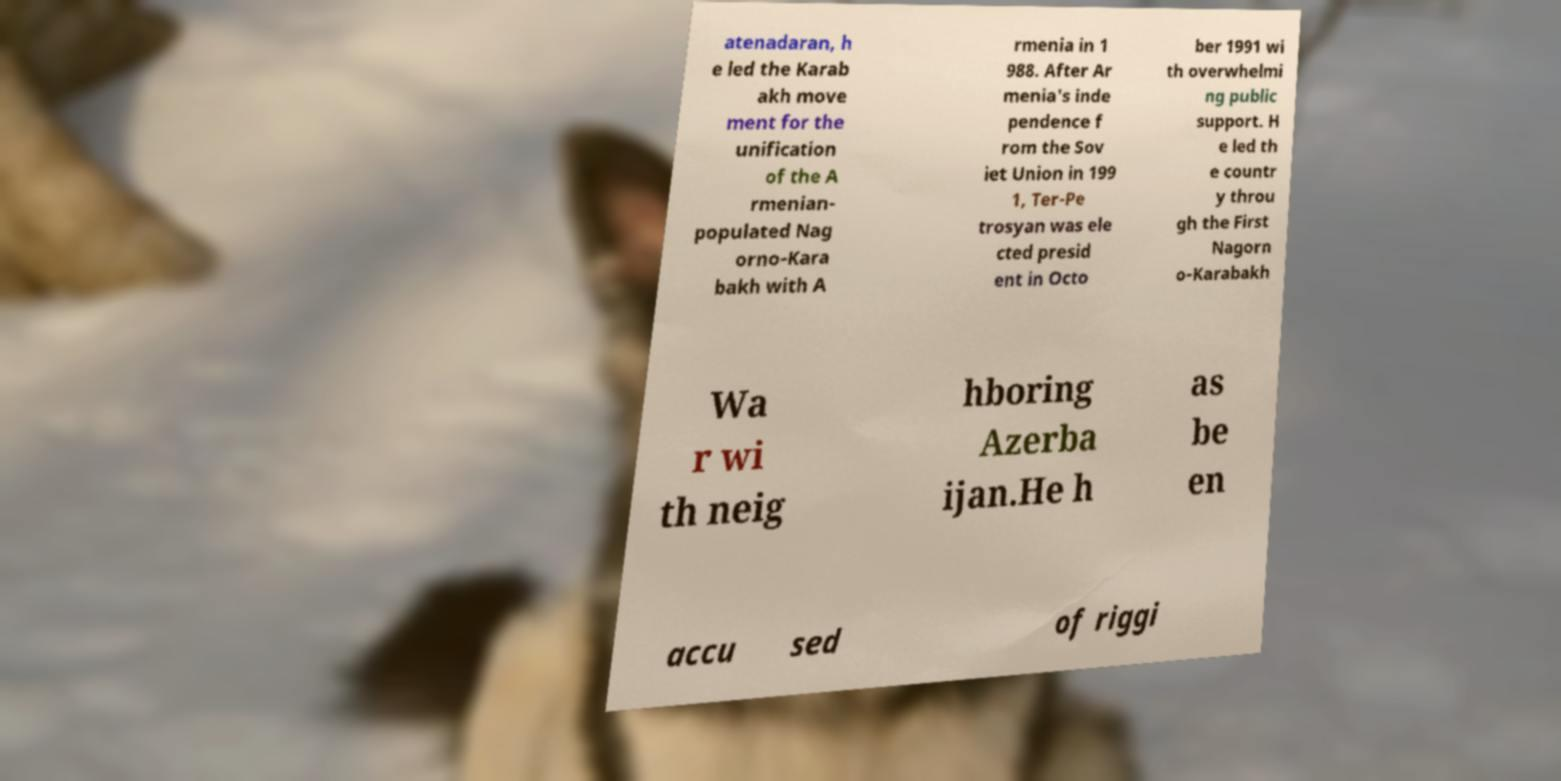There's text embedded in this image that I need extracted. Can you transcribe it verbatim? atenadaran, h e led the Karab akh move ment for the unification of the A rmenian- populated Nag orno-Kara bakh with A rmenia in 1 988. After Ar menia's inde pendence f rom the Sov iet Union in 199 1, Ter-Pe trosyan was ele cted presid ent in Octo ber 1991 wi th overwhelmi ng public support. H e led th e countr y throu gh the First Nagorn o-Karabakh Wa r wi th neig hboring Azerba ijan.He h as be en accu sed of riggi 